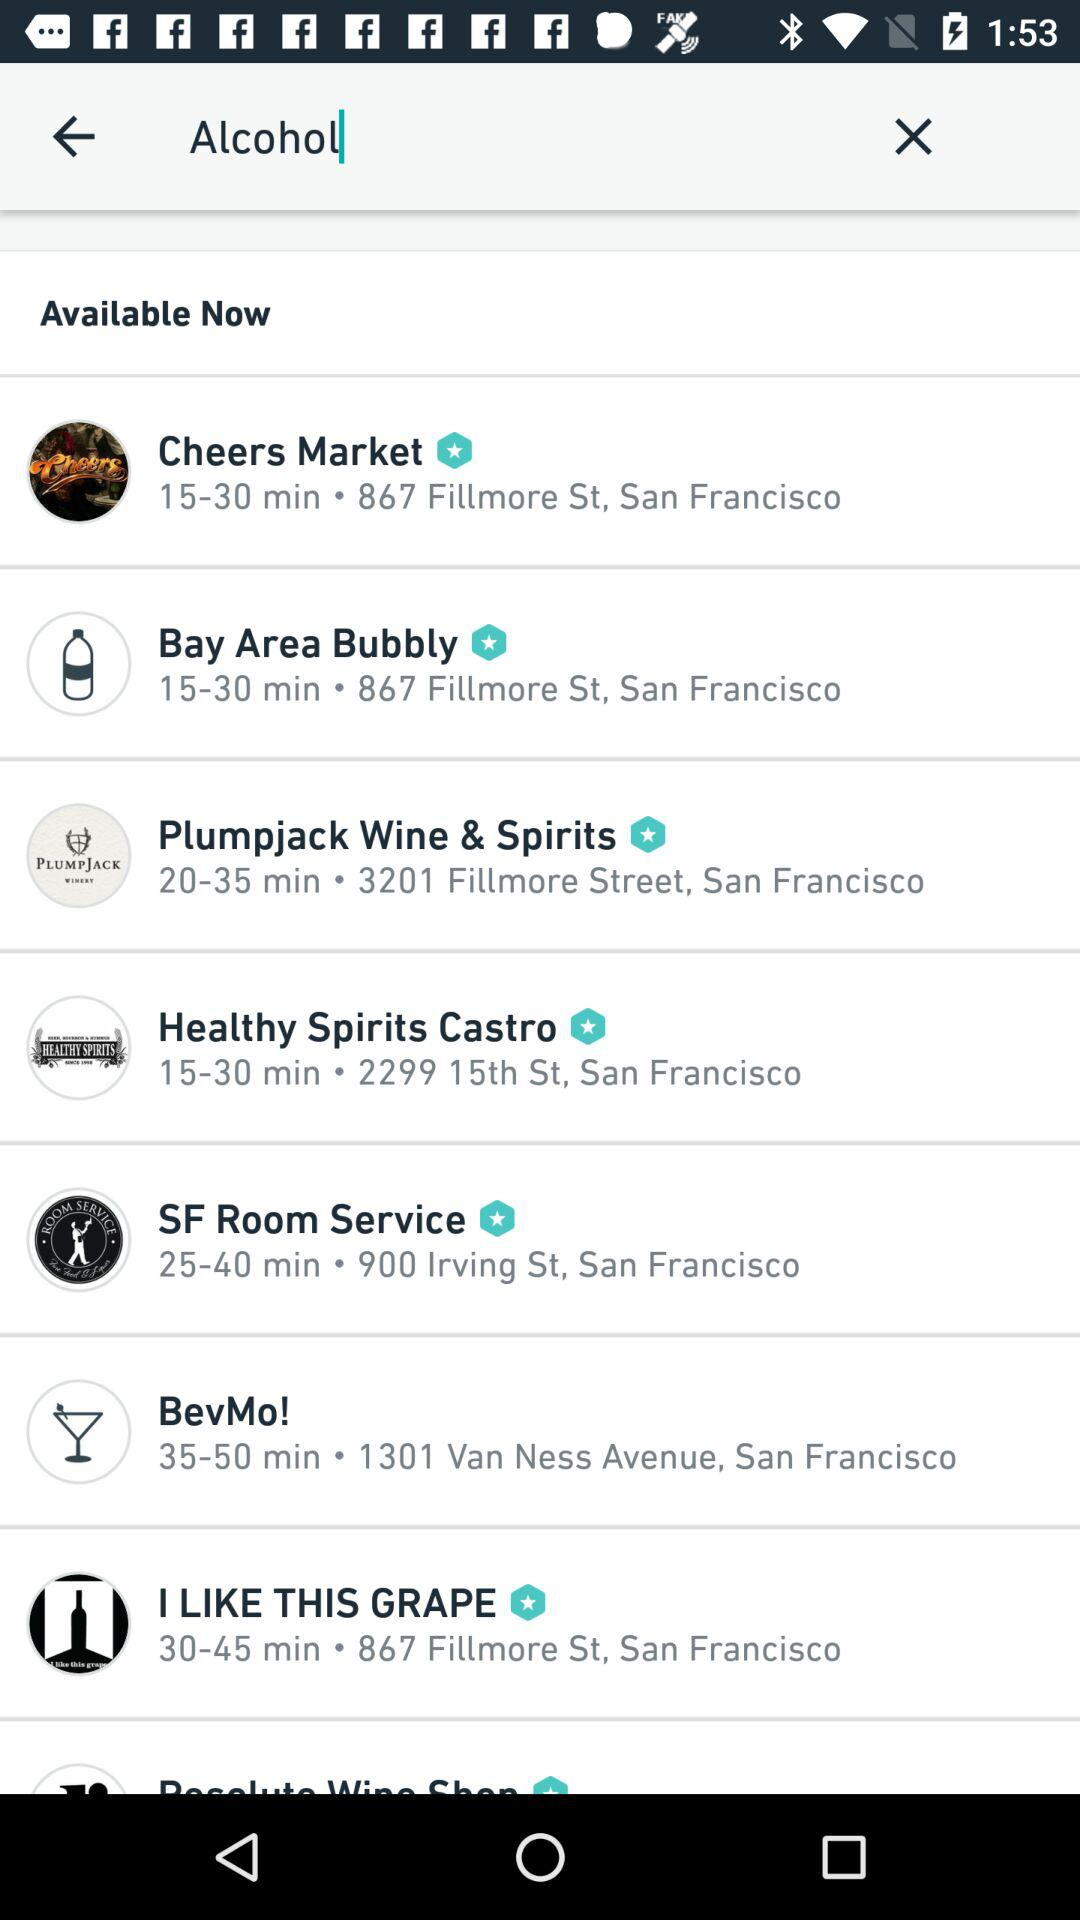What is the range of time it takes to travel to Cheer Market? It takes 15 to 30 minutes to travel to Cheer Market. 